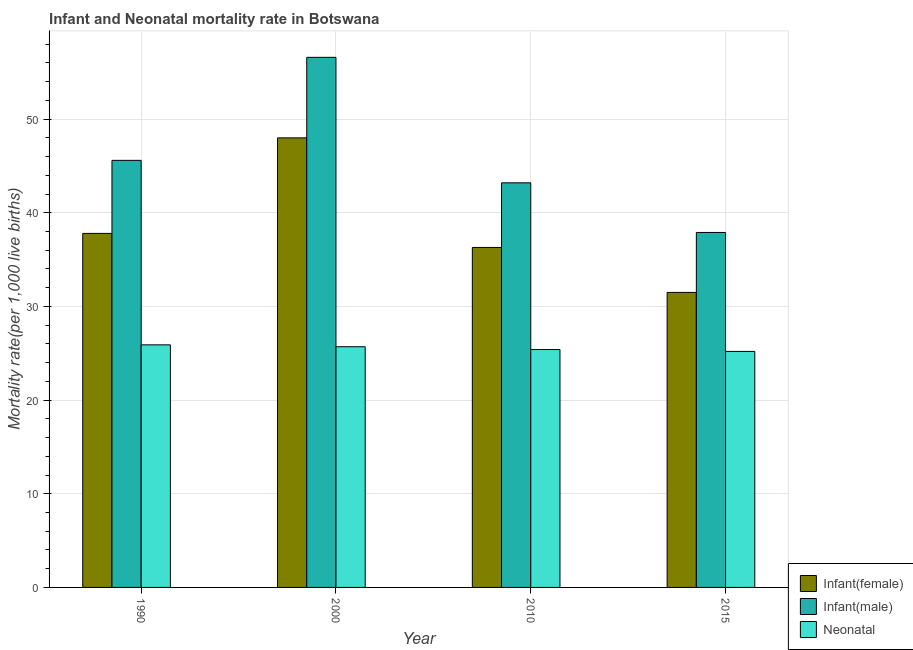How many groups of bars are there?
Ensure brevity in your answer.  4. Are the number of bars per tick equal to the number of legend labels?
Provide a short and direct response. Yes. How many bars are there on the 3rd tick from the left?
Your answer should be compact. 3. How many bars are there on the 4th tick from the right?
Your response must be concise. 3. What is the infant mortality rate(female) in 2015?
Ensure brevity in your answer.  31.5. Across all years, what is the maximum neonatal mortality rate?
Your answer should be very brief. 25.9. Across all years, what is the minimum infant mortality rate(male)?
Make the answer very short. 37.9. In which year was the infant mortality rate(male) minimum?
Provide a short and direct response. 2015. What is the total infant mortality rate(female) in the graph?
Ensure brevity in your answer.  153.6. What is the difference between the neonatal mortality rate in 1990 and that in 2015?
Keep it short and to the point. 0.7. What is the difference between the infant mortality rate(female) in 2015 and the infant mortality rate(male) in 1990?
Provide a succinct answer. -6.3. What is the average infant mortality rate(female) per year?
Offer a terse response. 38.4. In how many years, is the neonatal mortality rate greater than 14?
Provide a succinct answer. 4. What is the ratio of the infant mortality rate(male) in 1990 to that in 2000?
Offer a terse response. 0.81. Is the infant mortality rate(female) in 2000 less than that in 2015?
Provide a short and direct response. No. Is the difference between the infant mortality rate(female) in 2000 and 2015 greater than the difference between the neonatal mortality rate in 2000 and 2015?
Give a very brief answer. No. What is the difference between the highest and the second highest neonatal mortality rate?
Provide a short and direct response. 0.2. Is the sum of the neonatal mortality rate in 2010 and 2015 greater than the maximum infant mortality rate(male) across all years?
Keep it short and to the point. Yes. What does the 3rd bar from the left in 2000 represents?
Keep it short and to the point. Neonatal . What does the 1st bar from the right in 2015 represents?
Make the answer very short. Neonatal . Are all the bars in the graph horizontal?
Offer a terse response. No. How many years are there in the graph?
Keep it short and to the point. 4. Does the graph contain any zero values?
Give a very brief answer. No. How many legend labels are there?
Provide a succinct answer. 3. What is the title of the graph?
Ensure brevity in your answer.  Infant and Neonatal mortality rate in Botswana. What is the label or title of the Y-axis?
Your answer should be very brief. Mortality rate(per 1,0 live births). What is the Mortality rate(per 1,000 live births) of Infant(female) in 1990?
Your answer should be very brief. 37.8. What is the Mortality rate(per 1,000 live births) of Infant(male) in 1990?
Offer a terse response. 45.6. What is the Mortality rate(per 1,000 live births) of Neonatal  in 1990?
Offer a very short reply. 25.9. What is the Mortality rate(per 1,000 live births) of Infant(male) in 2000?
Your answer should be very brief. 56.6. What is the Mortality rate(per 1,000 live births) in Neonatal  in 2000?
Your answer should be compact. 25.7. What is the Mortality rate(per 1,000 live births) of Infant(female) in 2010?
Make the answer very short. 36.3. What is the Mortality rate(per 1,000 live births) in Infant(male) in 2010?
Offer a very short reply. 43.2. What is the Mortality rate(per 1,000 live births) in Neonatal  in 2010?
Offer a very short reply. 25.4. What is the Mortality rate(per 1,000 live births) in Infant(female) in 2015?
Your answer should be compact. 31.5. What is the Mortality rate(per 1,000 live births) in Infant(male) in 2015?
Give a very brief answer. 37.9. What is the Mortality rate(per 1,000 live births) of Neonatal  in 2015?
Your answer should be compact. 25.2. Across all years, what is the maximum Mortality rate(per 1,000 live births) of Infant(male)?
Your answer should be very brief. 56.6. Across all years, what is the maximum Mortality rate(per 1,000 live births) in Neonatal ?
Offer a terse response. 25.9. Across all years, what is the minimum Mortality rate(per 1,000 live births) in Infant(female)?
Provide a short and direct response. 31.5. Across all years, what is the minimum Mortality rate(per 1,000 live births) in Infant(male)?
Keep it short and to the point. 37.9. Across all years, what is the minimum Mortality rate(per 1,000 live births) in Neonatal ?
Offer a terse response. 25.2. What is the total Mortality rate(per 1,000 live births) in Infant(female) in the graph?
Your answer should be very brief. 153.6. What is the total Mortality rate(per 1,000 live births) in Infant(male) in the graph?
Your answer should be very brief. 183.3. What is the total Mortality rate(per 1,000 live births) of Neonatal  in the graph?
Your answer should be compact. 102.2. What is the difference between the Mortality rate(per 1,000 live births) of Infant(female) in 1990 and that in 2000?
Provide a short and direct response. -10.2. What is the difference between the Mortality rate(per 1,000 live births) in Neonatal  in 1990 and that in 2000?
Make the answer very short. 0.2. What is the difference between the Mortality rate(per 1,000 live births) of Infant(male) in 1990 and that in 2010?
Your answer should be compact. 2.4. What is the difference between the Mortality rate(per 1,000 live births) in Neonatal  in 1990 and that in 2010?
Your response must be concise. 0.5. What is the difference between the Mortality rate(per 1,000 live births) of Infant(female) in 1990 and that in 2015?
Your response must be concise. 6.3. What is the difference between the Mortality rate(per 1,000 live births) of Infant(female) in 2000 and that in 2010?
Ensure brevity in your answer.  11.7. What is the difference between the Mortality rate(per 1,000 live births) of Infant(male) in 2000 and that in 2010?
Provide a short and direct response. 13.4. What is the difference between the Mortality rate(per 1,000 live births) of Neonatal  in 2000 and that in 2010?
Your response must be concise. 0.3. What is the difference between the Mortality rate(per 1,000 live births) in Infant(female) in 2010 and that in 2015?
Your answer should be compact. 4.8. What is the difference between the Mortality rate(per 1,000 live births) of Neonatal  in 2010 and that in 2015?
Make the answer very short. 0.2. What is the difference between the Mortality rate(per 1,000 live births) in Infant(female) in 1990 and the Mortality rate(per 1,000 live births) in Infant(male) in 2000?
Provide a succinct answer. -18.8. What is the difference between the Mortality rate(per 1,000 live births) of Infant(female) in 1990 and the Mortality rate(per 1,000 live births) of Neonatal  in 2000?
Your answer should be compact. 12.1. What is the difference between the Mortality rate(per 1,000 live births) of Infant(male) in 1990 and the Mortality rate(per 1,000 live births) of Neonatal  in 2010?
Your response must be concise. 20.2. What is the difference between the Mortality rate(per 1,000 live births) in Infant(female) in 1990 and the Mortality rate(per 1,000 live births) in Infant(male) in 2015?
Your answer should be very brief. -0.1. What is the difference between the Mortality rate(per 1,000 live births) in Infant(female) in 1990 and the Mortality rate(per 1,000 live births) in Neonatal  in 2015?
Provide a short and direct response. 12.6. What is the difference between the Mortality rate(per 1,000 live births) of Infant(male) in 1990 and the Mortality rate(per 1,000 live births) of Neonatal  in 2015?
Your response must be concise. 20.4. What is the difference between the Mortality rate(per 1,000 live births) of Infant(female) in 2000 and the Mortality rate(per 1,000 live births) of Neonatal  in 2010?
Your answer should be compact. 22.6. What is the difference between the Mortality rate(per 1,000 live births) in Infant(male) in 2000 and the Mortality rate(per 1,000 live births) in Neonatal  in 2010?
Your answer should be very brief. 31.2. What is the difference between the Mortality rate(per 1,000 live births) of Infant(female) in 2000 and the Mortality rate(per 1,000 live births) of Neonatal  in 2015?
Your answer should be compact. 22.8. What is the difference between the Mortality rate(per 1,000 live births) of Infant(male) in 2000 and the Mortality rate(per 1,000 live births) of Neonatal  in 2015?
Your response must be concise. 31.4. What is the difference between the Mortality rate(per 1,000 live births) in Infant(female) in 2010 and the Mortality rate(per 1,000 live births) in Neonatal  in 2015?
Ensure brevity in your answer.  11.1. What is the difference between the Mortality rate(per 1,000 live births) of Infant(male) in 2010 and the Mortality rate(per 1,000 live births) of Neonatal  in 2015?
Provide a succinct answer. 18. What is the average Mortality rate(per 1,000 live births) in Infant(female) per year?
Provide a succinct answer. 38.4. What is the average Mortality rate(per 1,000 live births) of Infant(male) per year?
Provide a succinct answer. 45.83. What is the average Mortality rate(per 1,000 live births) in Neonatal  per year?
Your answer should be compact. 25.55. In the year 1990, what is the difference between the Mortality rate(per 1,000 live births) of Infant(female) and Mortality rate(per 1,000 live births) of Neonatal ?
Keep it short and to the point. 11.9. In the year 1990, what is the difference between the Mortality rate(per 1,000 live births) in Infant(male) and Mortality rate(per 1,000 live births) in Neonatal ?
Give a very brief answer. 19.7. In the year 2000, what is the difference between the Mortality rate(per 1,000 live births) of Infant(female) and Mortality rate(per 1,000 live births) of Infant(male)?
Make the answer very short. -8.6. In the year 2000, what is the difference between the Mortality rate(per 1,000 live births) in Infant(female) and Mortality rate(per 1,000 live births) in Neonatal ?
Offer a very short reply. 22.3. In the year 2000, what is the difference between the Mortality rate(per 1,000 live births) of Infant(male) and Mortality rate(per 1,000 live births) of Neonatal ?
Your answer should be very brief. 30.9. In the year 2015, what is the difference between the Mortality rate(per 1,000 live births) in Infant(female) and Mortality rate(per 1,000 live births) in Infant(male)?
Keep it short and to the point. -6.4. In the year 2015, what is the difference between the Mortality rate(per 1,000 live births) in Infant(female) and Mortality rate(per 1,000 live births) in Neonatal ?
Keep it short and to the point. 6.3. What is the ratio of the Mortality rate(per 1,000 live births) of Infant(female) in 1990 to that in 2000?
Offer a very short reply. 0.79. What is the ratio of the Mortality rate(per 1,000 live births) of Infant(male) in 1990 to that in 2000?
Give a very brief answer. 0.81. What is the ratio of the Mortality rate(per 1,000 live births) in Neonatal  in 1990 to that in 2000?
Give a very brief answer. 1.01. What is the ratio of the Mortality rate(per 1,000 live births) in Infant(female) in 1990 to that in 2010?
Offer a very short reply. 1.04. What is the ratio of the Mortality rate(per 1,000 live births) in Infant(male) in 1990 to that in 2010?
Keep it short and to the point. 1.06. What is the ratio of the Mortality rate(per 1,000 live births) of Neonatal  in 1990 to that in 2010?
Give a very brief answer. 1.02. What is the ratio of the Mortality rate(per 1,000 live births) of Infant(male) in 1990 to that in 2015?
Your response must be concise. 1.2. What is the ratio of the Mortality rate(per 1,000 live births) of Neonatal  in 1990 to that in 2015?
Your response must be concise. 1.03. What is the ratio of the Mortality rate(per 1,000 live births) of Infant(female) in 2000 to that in 2010?
Your response must be concise. 1.32. What is the ratio of the Mortality rate(per 1,000 live births) in Infant(male) in 2000 to that in 2010?
Make the answer very short. 1.31. What is the ratio of the Mortality rate(per 1,000 live births) in Neonatal  in 2000 to that in 2010?
Offer a terse response. 1.01. What is the ratio of the Mortality rate(per 1,000 live births) of Infant(female) in 2000 to that in 2015?
Your answer should be very brief. 1.52. What is the ratio of the Mortality rate(per 1,000 live births) in Infant(male) in 2000 to that in 2015?
Your response must be concise. 1.49. What is the ratio of the Mortality rate(per 1,000 live births) in Neonatal  in 2000 to that in 2015?
Your response must be concise. 1.02. What is the ratio of the Mortality rate(per 1,000 live births) of Infant(female) in 2010 to that in 2015?
Provide a short and direct response. 1.15. What is the ratio of the Mortality rate(per 1,000 live births) in Infant(male) in 2010 to that in 2015?
Provide a short and direct response. 1.14. What is the ratio of the Mortality rate(per 1,000 live births) in Neonatal  in 2010 to that in 2015?
Offer a very short reply. 1.01. What is the difference between the highest and the second highest Mortality rate(per 1,000 live births) in Infant(female)?
Offer a terse response. 10.2. What is the difference between the highest and the second highest Mortality rate(per 1,000 live births) in Neonatal ?
Your response must be concise. 0.2. What is the difference between the highest and the lowest Mortality rate(per 1,000 live births) of Infant(male)?
Your answer should be very brief. 18.7. What is the difference between the highest and the lowest Mortality rate(per 1,000 live births) of Neonatal ?
Your answer should be compact. 0.7. 